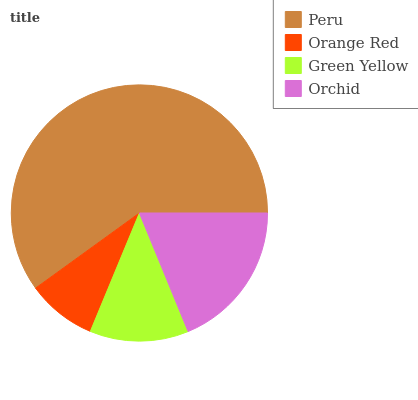Is Orange Red the minimum?
Answer yes or no. Yes. Is Peru the maximum?
Answer yes or no. Yes. Is Green Yellow the minimum?
Answer yes or no. No. Is Green Yellow the maximum?
Answer yes or no. No. Is Green Yellow greater than Orange Red?
Answer yes or no. Yes. Is Orange Red less than Green Yellow?
Answer yes or no. Yes. Is Orange Red greater than Green Yellow?
Answer yes or no. No. Is Green Yellow less than Orange Red?
Answer yes or no. No. Is Orchid the high median?
Answer yes or no. Yes. Is Green Yellow the low median?
Answer yes or no. Yes. Is Peru the high median?
Answer yes or no. No. Is Peru the low median?
Answer yes or no. No. 